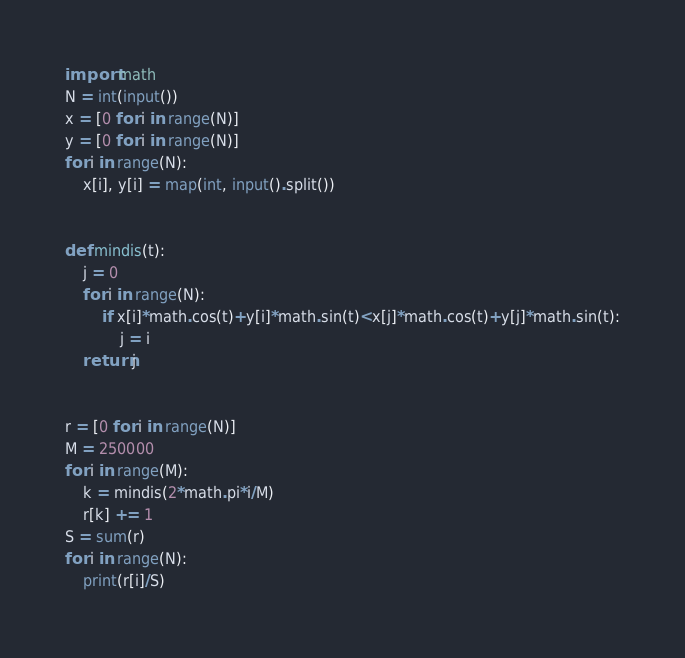Convert code to text. <code><loc_0><loc_0><loc_500><loc_500><_Python_>import math
N = int(input())
x = [0 for i in range(N)]
y = [0 for i in range(N)]
for i in range(N):
    x[i], y[i] = map(int, input().split())


def mindis(t):
    j = 0
    for i in range(N):
        if x[i]*math.cos(t)+y[i]*math.sin(t)<x[j]*math.cos(t)+y[j]*math.sin(t):
            j = i
    return j


r = [0 for i in range(N)]
M = 250000
for i in range(M):
    k = mindis(2*math.pi*i/M)
    r[k] += 1
S = sum(r)
for i in range(N):
    print(r[i]/S)
</code> 